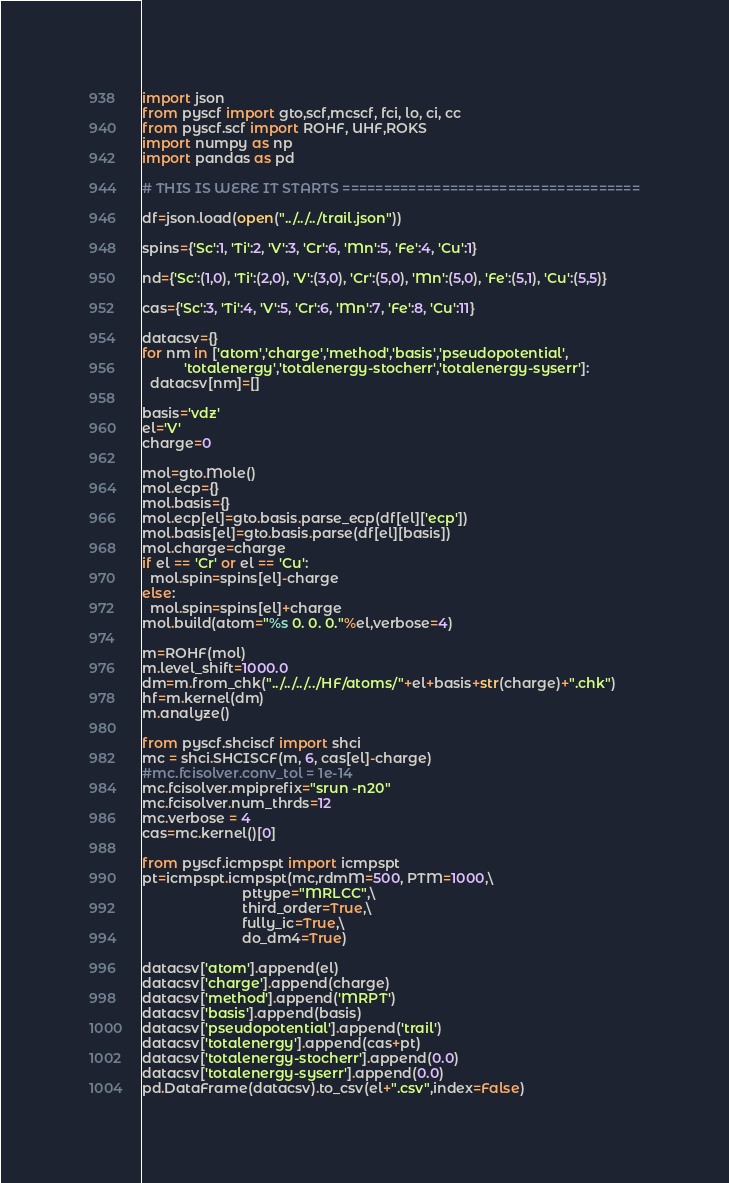<code> <loc_0><loc_0><loc_500><loc_500><_Python_>import json
from pyscf import gto,scf,mcscf, fci, lo, ci, cc
from pyscf.scf import ROHF, UHF,ROKS
import numpy as np
import pandas as pd

# THIS IS WERE IT STARTS ====================================

df=json.load(open("../../../trail.json"))

spins={'Sc':1, 'Ti':2, 'V':3, 'Cr':6, 'Mn':5, 'Fe':4, 'Cu':1}

nd={'Sc':(1,0), 'Ti':(2,0), 'V':(3,0), 'Cr':(5,0), 'Mn':(5,0), 'Fe':(5,1), 'Cu':(5,5)}

cas={'Sc':3, 'Ti':4, 'V':5, 'Cr':6, 'Mn':7, 'Fe':8, 'Cu':11}

datacsv={}
for nm in ['atom','charge','method','basis','pseudopotential',
           'totalenergy','totalenergy-stocherr','totalenergy-syserr']:
  datacsv[nm]=[]

basis='vdz'
el='V'
charge=0

mol=gto.Mole()
mol.ecp={}
mol.basis={}
mol.ecp[el]=gto.basis.parse_ecp(df[el]['ecp'])
mol.basis[el]=gto.basis.parse(df[el][basis])
mol.charge=charge
if el == 'Cr' or el == 'Cu':
  mol.spin=spins[el]-charge
else:
  mol.spin=spins[el]+charge
mol.build(atom="%s 0. 0. 0."%el,verbose=4)

m=ROHF(mol)
m.level_shift=1000.0
dm=m.from_chk("../../../../HF/atoms/"+el+basis+str(charge)+".chk")
hf=m.kernel(dm)
m.analyze()

from pyscf.shciscf import shci
mc = shci.SHCISCF(m, 6, cas[el]-charge)
#mc.fcisolver.conv_tol = 1e-14
mc.fcisolver.mpiprefix="srun -n20"
mc.fcisolver.num_thrds=12
mc.verbose = 4
cas=mc.kernel()[0]
 
from pyscf.icmpspt import icmpspt
pt=icmpspt.icmpspt(mc,rdmM=500, PTM=1000,\
                          pttype="MRLCC",\
                          third_order=True,\
                          fully_ic=True,\
                          do_dm4=True)

datacsv['atom'].append(el)
datacsv['charge'].append(charge)
datacsv['method'].append('MRPT')
datacsv['basis'].append(basis)
datacsv['pseudopotential'].append('trail')
datacsv['totalenergy'].append(cas+pt)
datacsv['totalenergy-stocherr'].append(0.0)
datacsv['totalenergy-syserr'].append(0.0)
pd.DataFrame(datacsv).to_csv(el+".csv",index=False)

</code> 